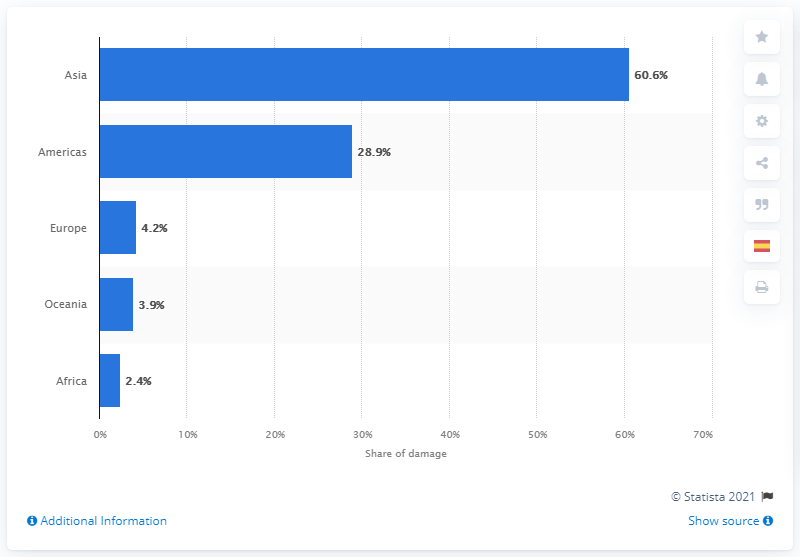Identify some key points in this picture. According to data from 2019, Asia was the continent that suffered the most significant economic losses due to natural disasters. 